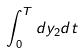Convert formula to latex. <formula><loc_0><loc_0><loc_500><loc_500>\int _ { 0 } ^ { T } d y _ { 2 } d t</formula> 